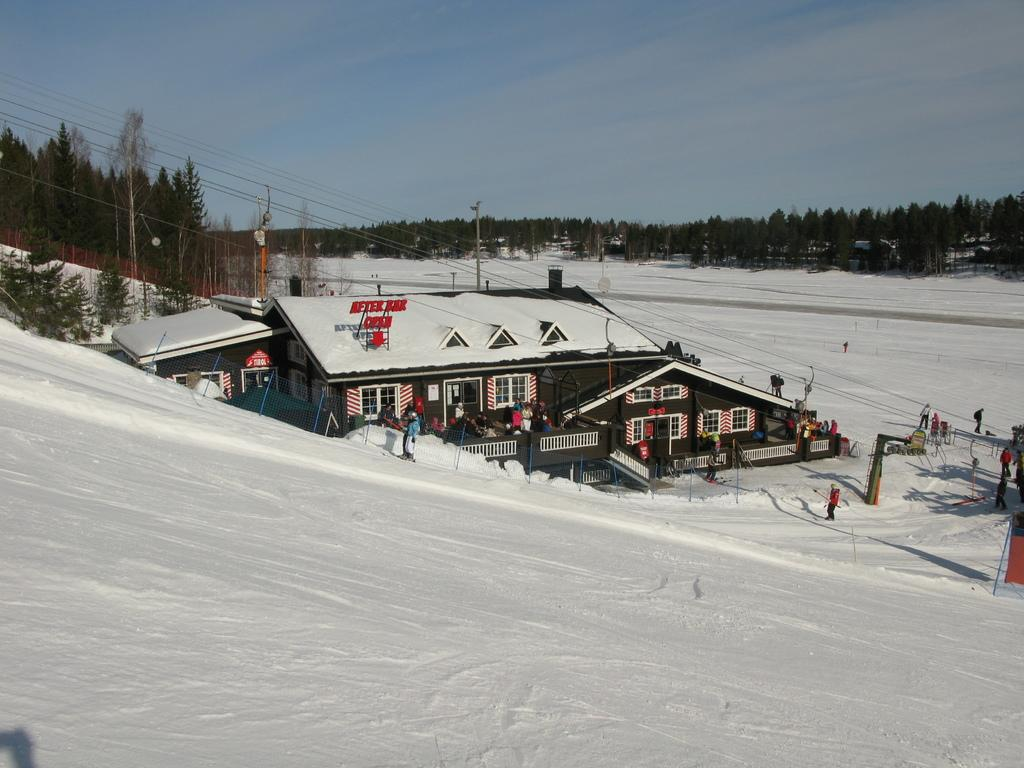What structures are located in the center of the image? There are sheds in the center of the image. What type of weather is depicted in the image? There is snow at the bottom of the image, indicating cold weather. What can be seen in the background of the image? There are trees and poles in the background of the image, as well as the sky. What are the people in the image doing? There are people walking on the right side of the image. What type of bells can be heard ringing in the image? There are no bells present in the image, and therefore no sound can be heard. How does the ice affect the movement of the people in the image? The ice is not mentioned in the image, and there is no indication of its presence or effect on the people walking. 